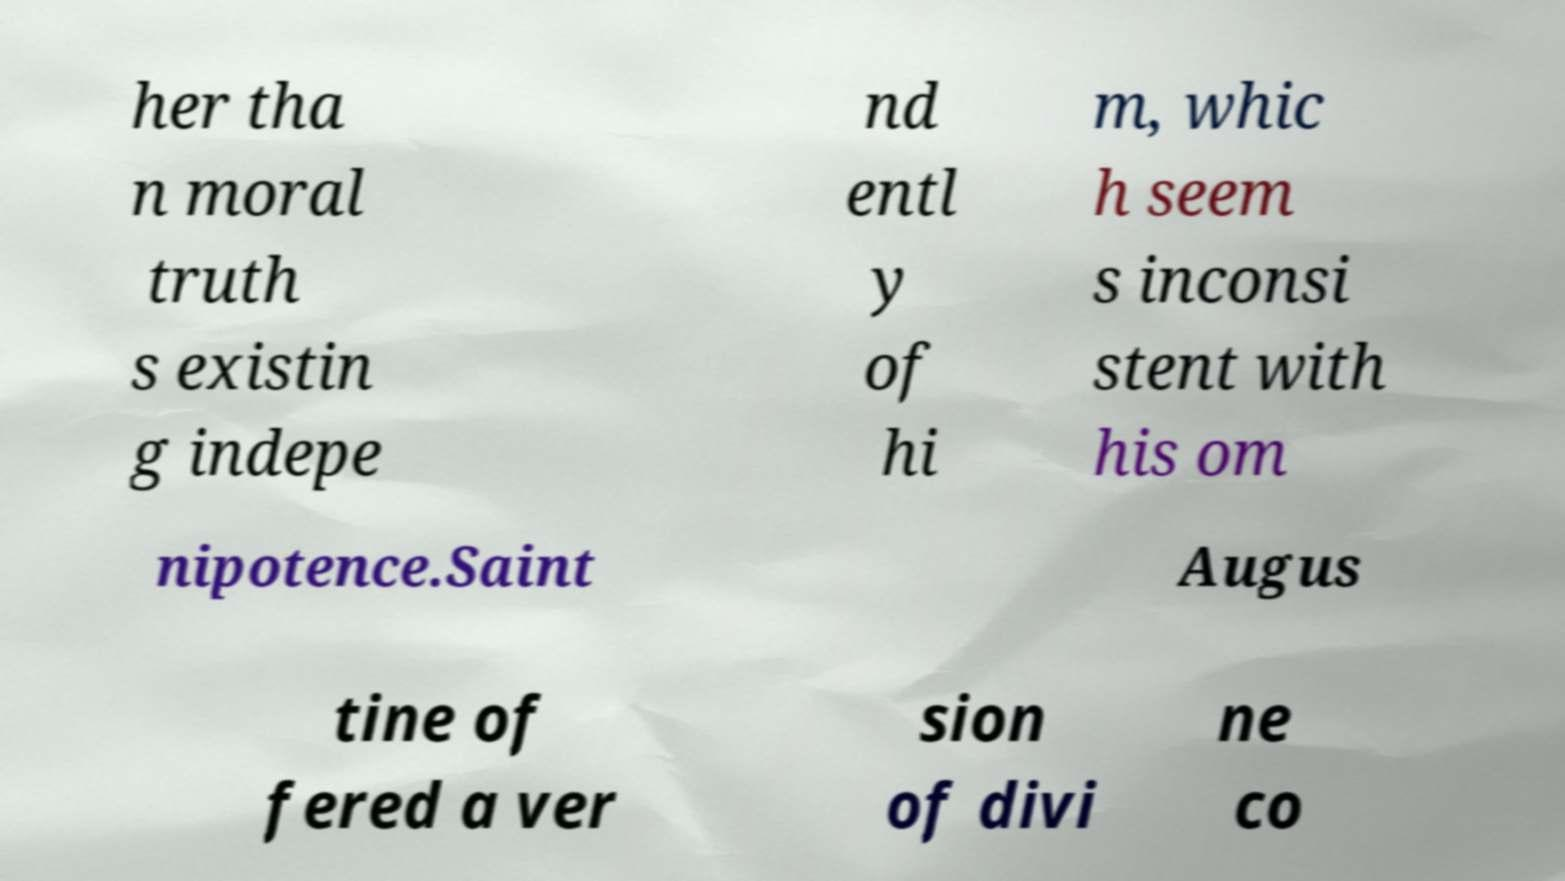There's text embedded in this image that I need extracted. Can you transcribe it verbatim? her tha n moral truth s existin g indepe nd entl y of hi m, whic h seem s inconsi stent with his om nipotence.Saint Augus tine of fered a ver sion of divi ne co 